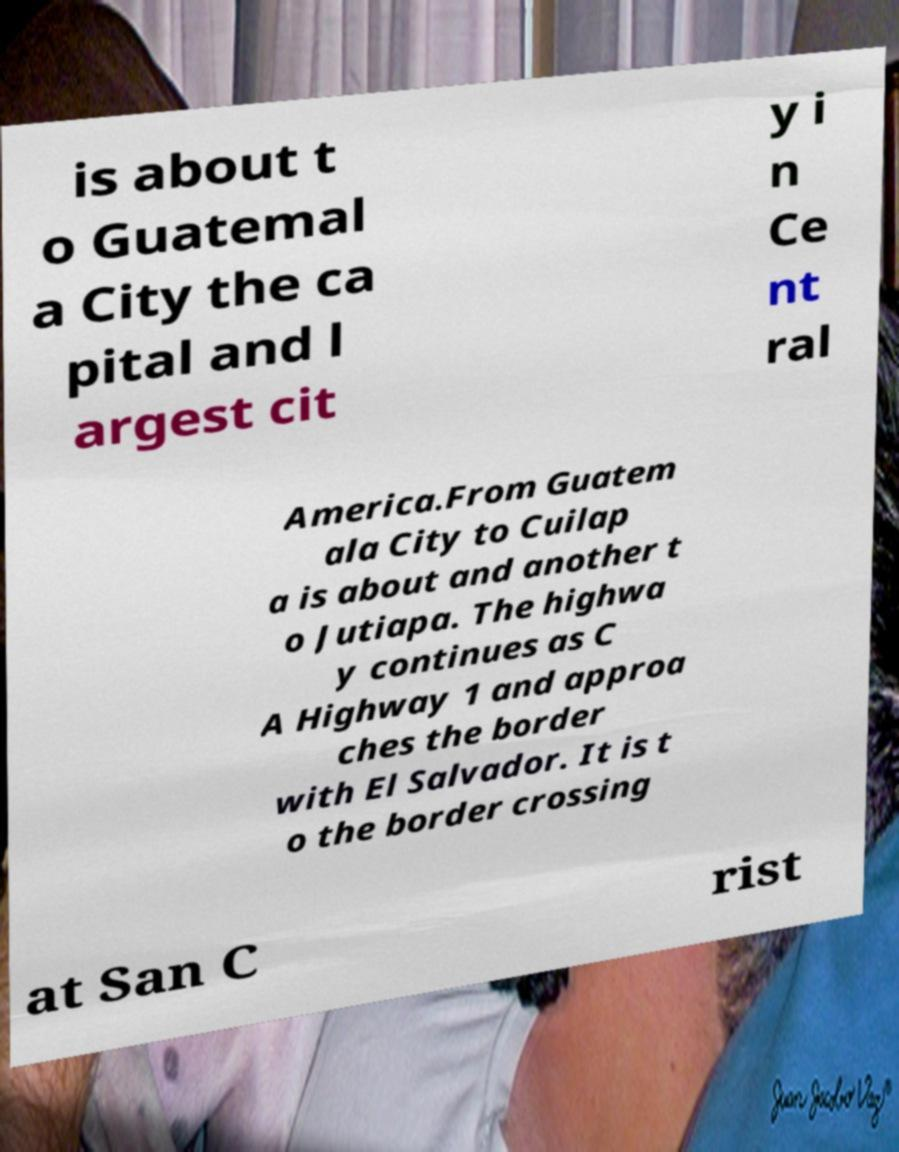What messages or text are displayed in this image? I need them in a readable, typed format. is about t o Guatemal a City the ca pital and l argest cit y i n Ce nt ral America.From Guatem ala City to Cuilap a is about and another t o Jutiapa. The highwa y continues as C A Highway 1 and approa ches the border with El Salvador. It is t o the border crossing at San C rist 